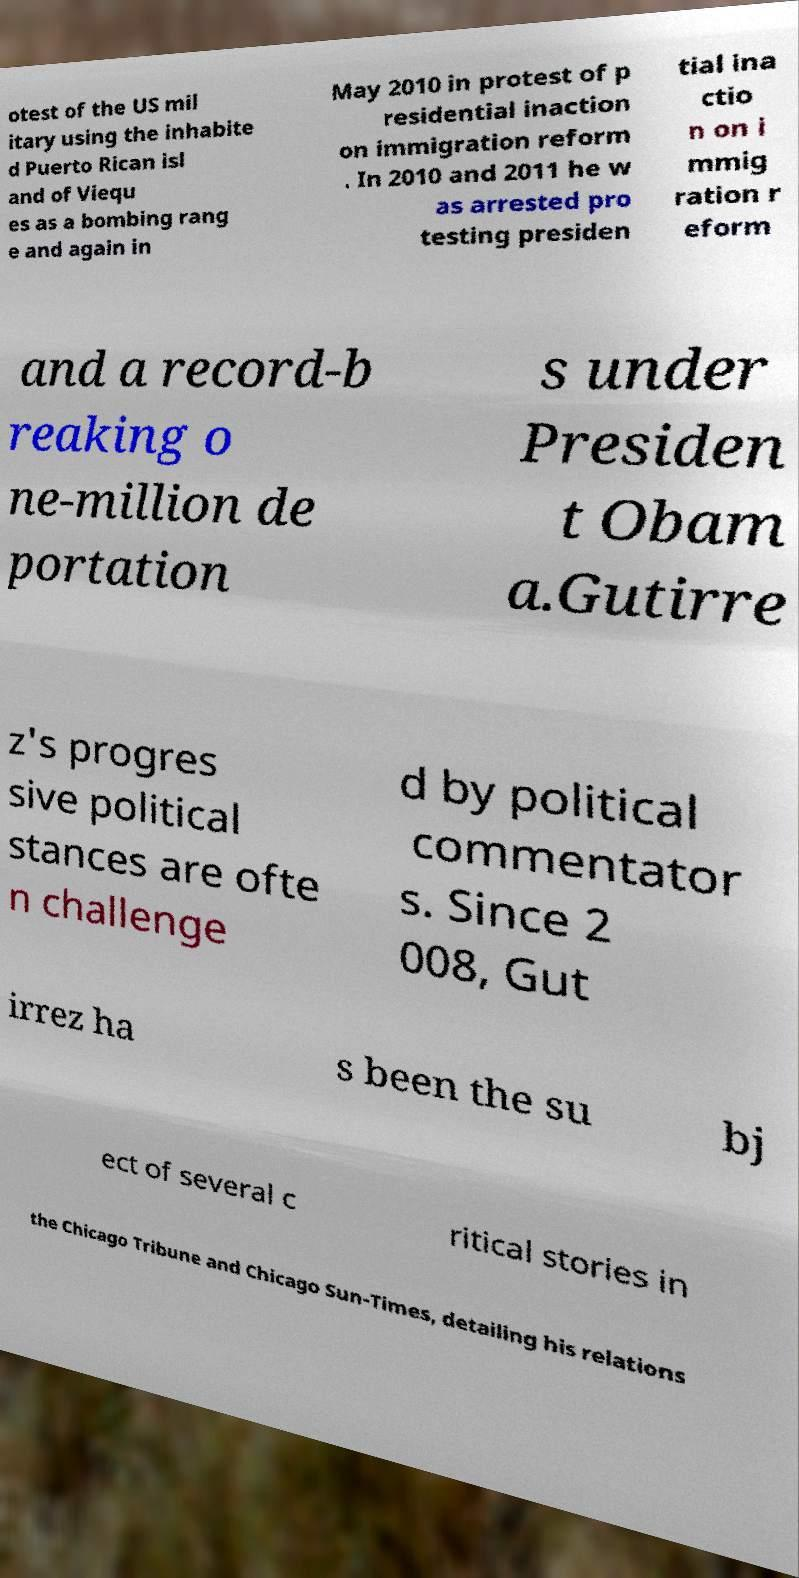Could you extract and type out the text from this image? otest of the US mil itary using the inhabite d Puerto Rican isl and of Viequ es as a bombing rang e and again in May 2010 in protest of p residential inaction on immigration reform . In 2010 and 2011 he w as arrested pro testing presiden tial ina ctio n on i mmig ration r eform and a record-b reaking o ne-million de portation s under Presiden t Obam a.Gutirre z's progres sive political stances are ofte n challenge d by political commentator s. Since 2 008, Gut irrez ha s been the su bj ect of several c ritical stories in the Chicago Tribune and Chicago Sun-Times, detailing his relations 